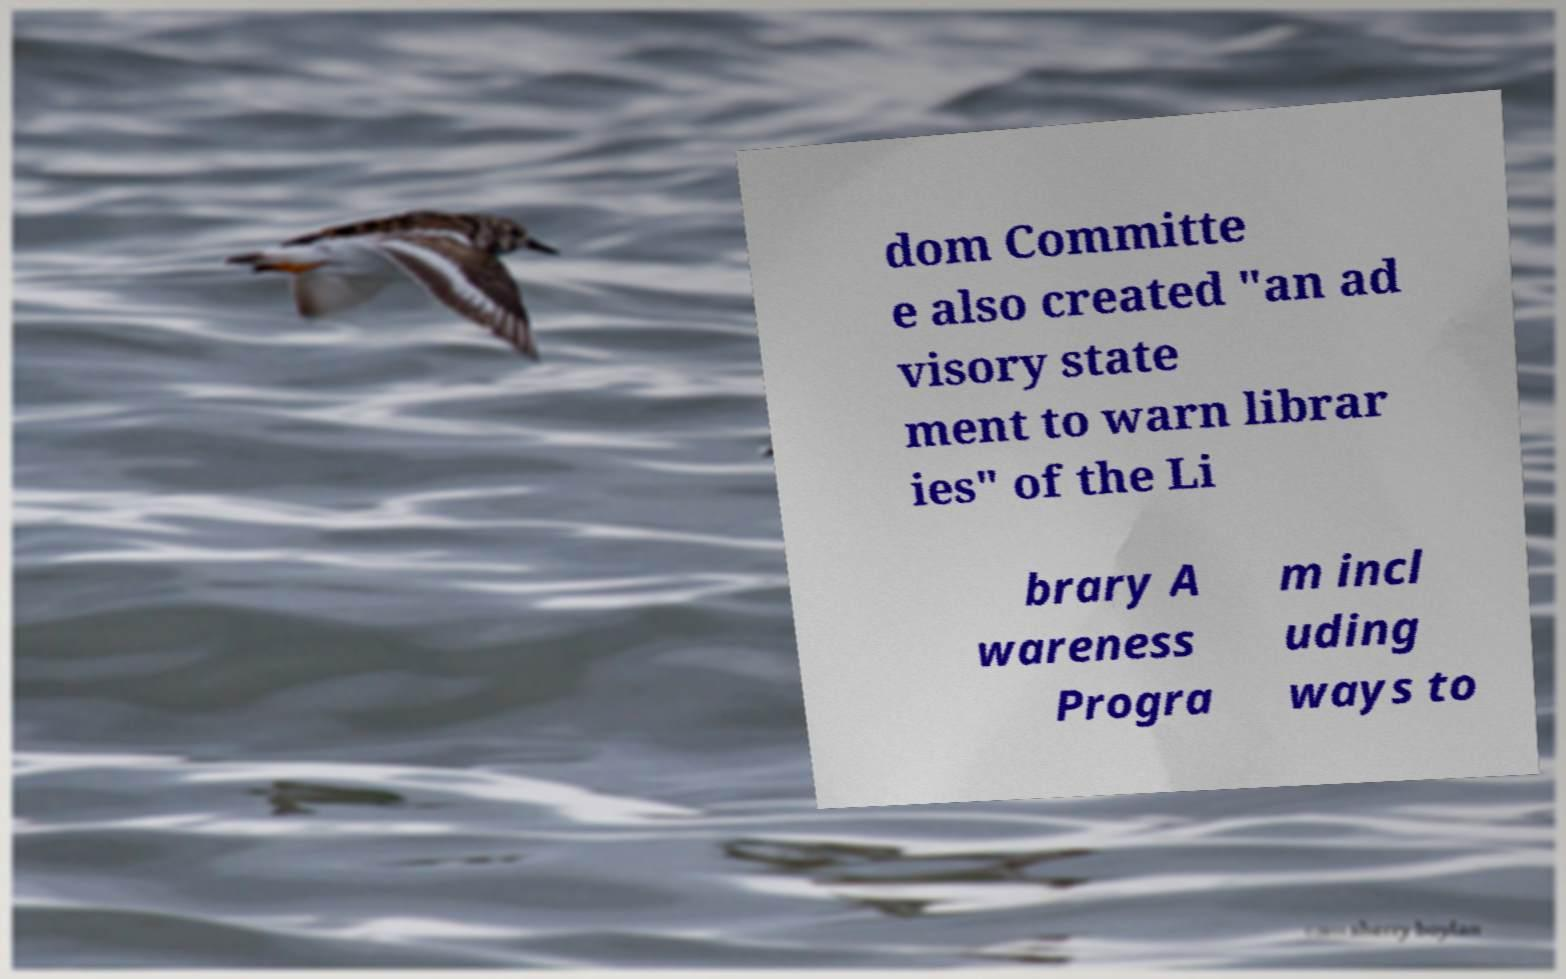There's text embedded in this image that I need extracted. Can you transcribe it verbatim? dom Committe e also created "an ad visory state ment to warn librar ies" of the Li brary A wareness Progra m incl uding ways to 